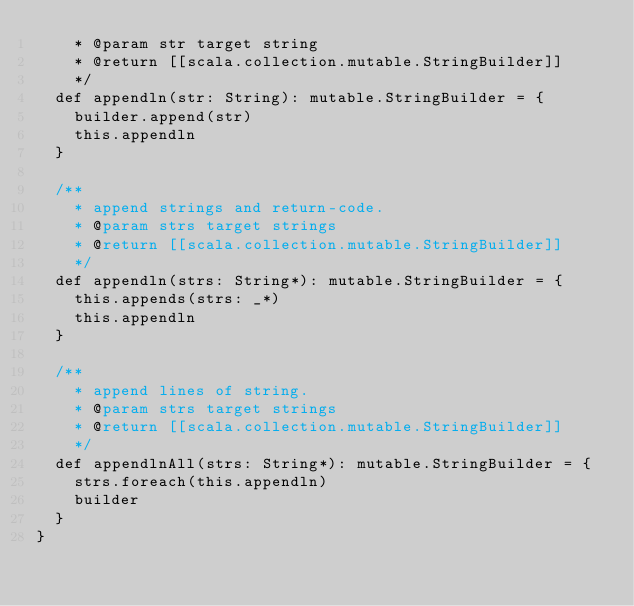Convert code to text. <code><loc_0><loc_0><loc_500><loc_500><_Scala_>    * @param str target string
    * @return [[scala.collection.mutable.StringBuilder]]
    */
  def appendln(str: String): mutable.StringBuilder = {
    builder.append(str)
    this.appendln
  }

  /**
    * append strings and return-code.
    * @param strs target strings
    * @return [[scala.collection.mutable.StringBuilder]]
    */
  def appendln(strs: String*): mutable.StringBuilder = {
    this.appends(strs: _*)
    this.appendln
  }

  /**
    * append lines of string.
    * @param strs target strings
    * @return [[scala.collection.mutable.StringBuilder]]
    */
  def appendlnAll(strs: String*): mutable.StringBuilder = {
    strs.foreach(this.appendln)
    builder
  }
}
</code> 